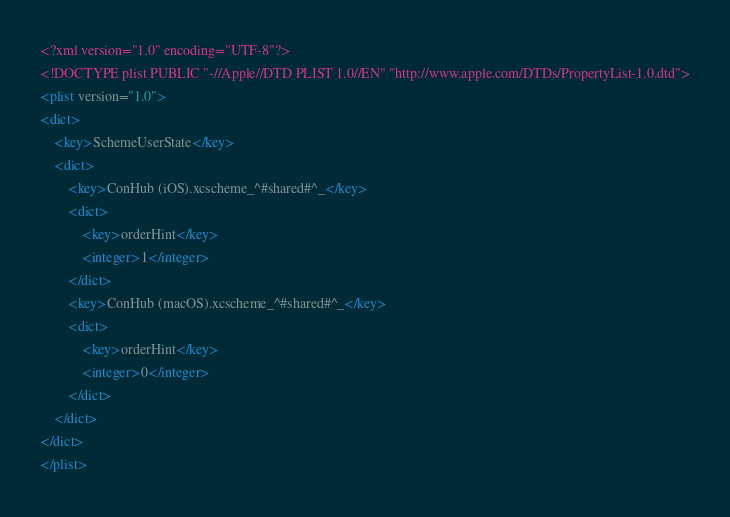<code> <loc_0><loc_0><loc_500><loc_500><_XML_><?xml version="1.0" encoding="UTF-8"?>
<!DOCTYPE plist PUBLIC "-//Apple//DTD PLIST 1.0//EN" "http://www.apple.com/DTDs/PropertyList-1.0.dtd">
<plist version="1.0">
<dict>
	<key>SchemeUserState</key>
	<dict>
		<key>ConHub (iOS).xcscheme_^#shared#^_</key>
		<dict>
			<key>orderHint</key>
			<integer>1</integer>
		</dict>
		<key>ConHub (macOS).xcscheme_^#shared#^_</key>
		<dict>
			<key>orderHint</key>
			<integer>0</integer>
		</dict>
	</dict>
</dict>
</plist>
</code> 